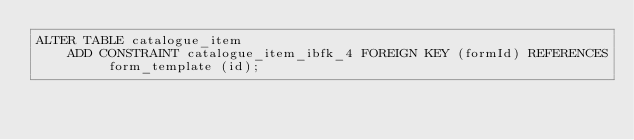<code> <loc_0><loc_0><loc_500><loc_500><_SQL_>ALTER TABLE catalogue_item
    ADD CONSTRAINT catalogue_item_ibfk_4 FOREIGN KEY (formId) REFERENCES form_template (id);
</code> 